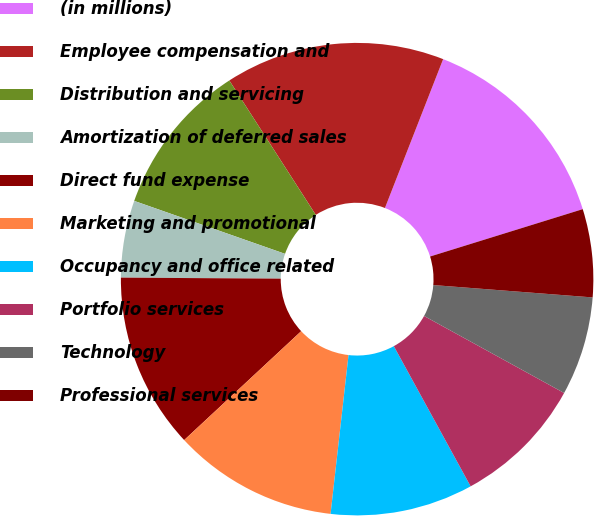Convert chart. <chart><loc_0><loc_0><loc_500><loc_500><pie_chart><fcel>(in millions)<fcel>Employee compensation and<fcel>Distribution and servicing<fcel>Amortization of deferred sales<fcel>Direct fund expense<fcel>Marketing and promotional<fcel>Occupancy and office related<fcel>Portfolio services<fcel>Technology<fcel>Professional services<nl><fcel>14.28%<fcel>15.03%<fcel>10.53%<fcel>5.27%<fcel>12.03%<fcel>11.28%<fcel>9.77%<fcel>9.02%<fcel>6.77%<fcel>6.02%<nl></chart> 